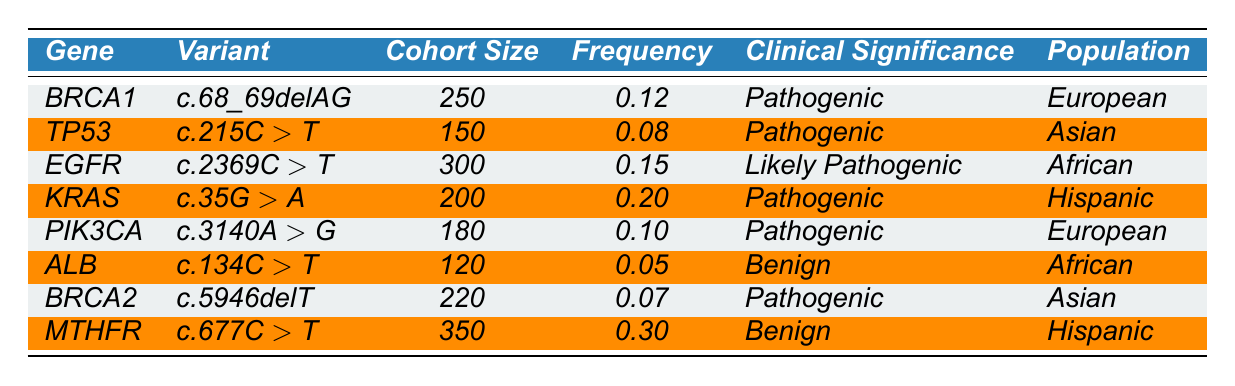What is the clinical significance of the KRAS variant? The table directly lists the clinical significance for the KRAS variant (c.35G > A), which is stated as 'Pathogenic.'
Answer: Pathogenic Which gene has the highest variant allele frequency in this cohort? Looking at the frequency column, MTHFR has the highest value of 0.30.
Answer: MTHFR How many individuals in total are included in the cohort for EGFR and TP53? The cohort sizes for EGFR and TP53 are 300 and 150 respectively. Adding them gives 300 + 150 = 450.
Answer: 450 Is the ALB variant classified as pathogenic? The clinical significance for the ALB variant is listed as 'Benign,' not pathogenic.
Answer: No What is the average frequency of pathogenic variants in the cohort? The pathogenic variants are from BRCA1 (0.12), TP53 (0.08), EGFR (0.15), KRAS (0.20), PIK3CA (0.10), and BRCA2 (0.07). Their sum is 0.12 + 0.08 + 0.15 + 0.20 + 0.10 + 0.07 = 0.72. There are 6 pathogenic variants, so the average frequency is 0.72 / 6 = 0.12.
Answer: 0.12 Which variant has the lowest allele frequency and what is its clinical significance? The lowest frequency is for the ALB variant at 0.05, which is classified as 'Benign.'
Answer: ALB, Benign If you combine the cohort sizes of the European population, what will be the total? The cohort sizes for the European population are for BRCA1 (250) and PIK3CA (180), with a total of 250 + 180 = 430.
Answer: 430 Are there any benign variants in the Hispanic population? MTHFR is categorized as 'Benign' and belongs to the Hispanic population.
Answer: Yes What percentage of the total cohort size does the EGFR variant represent? The total cohort size is 250 + 150 + 300 + 200 + 180 + 120 + 220 + 350 = 1870. The EGFR cohort size is 300, so the percentage is (300 / 1870) * 100 ≈ 16.02%.
Answer: ≈ 16.02% 